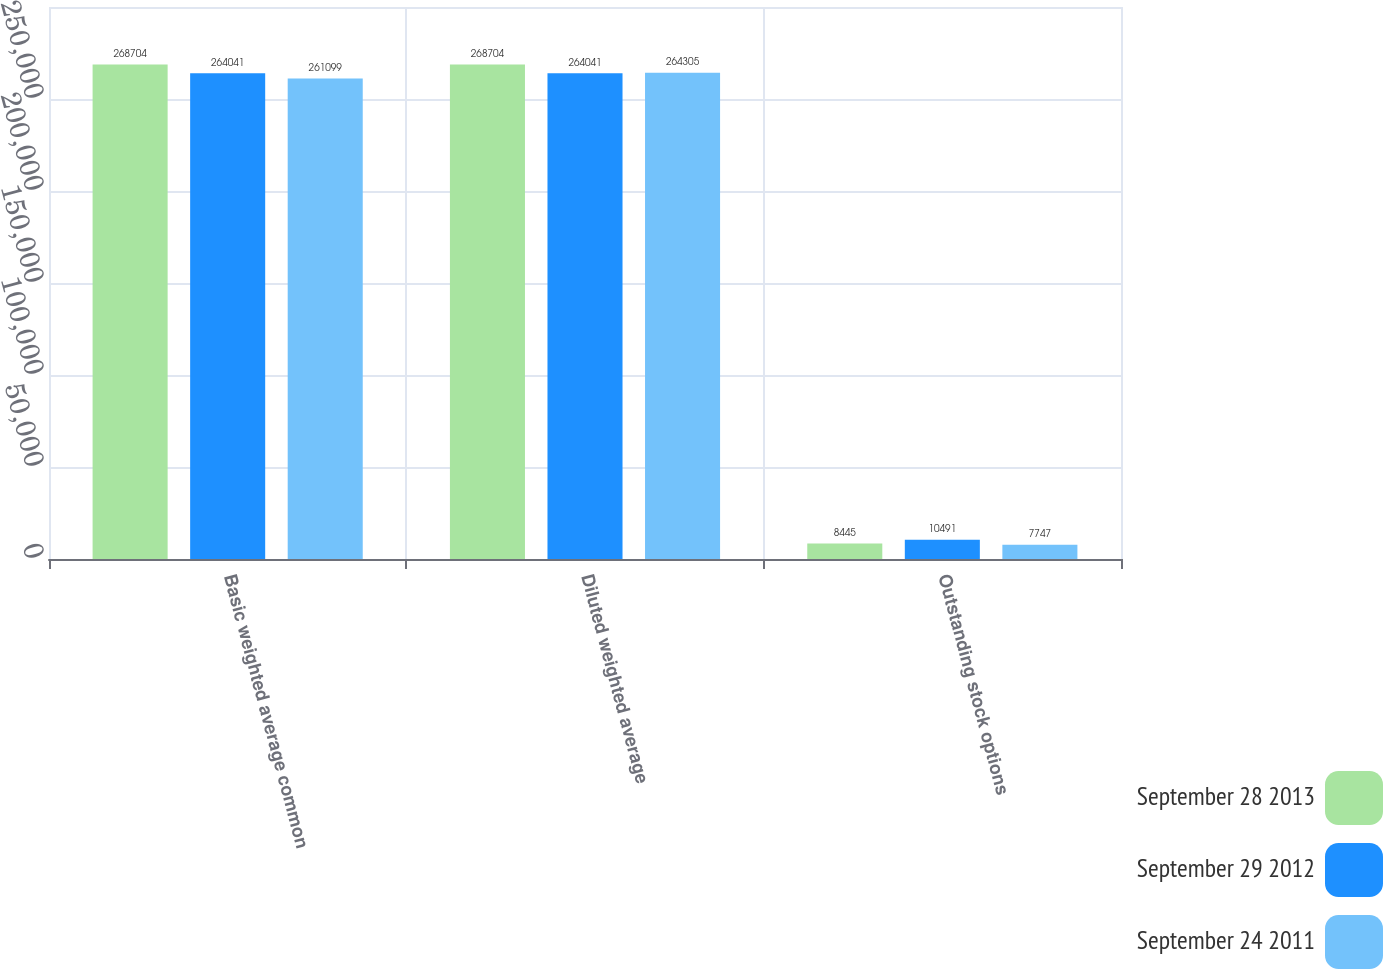Convert chart to OTSL. <chart><loc_0><loc_0><loc_500><loc_500><stacked_bar_chart><ecel><fcel>Basic weighted average common<fcel>Diluted weighted average<fcel>Outstanding stock options<nl><fcel>September 28 2013<fcel>268704<fcel>268704<fcel>8445<nl><fcel>September 29 2012<fcel>264041<fcel>264041<fcel>10491<nl><fcel>September 24 2011<fcel>261099<fcel>264305<fcel>7747<nl></chart> 